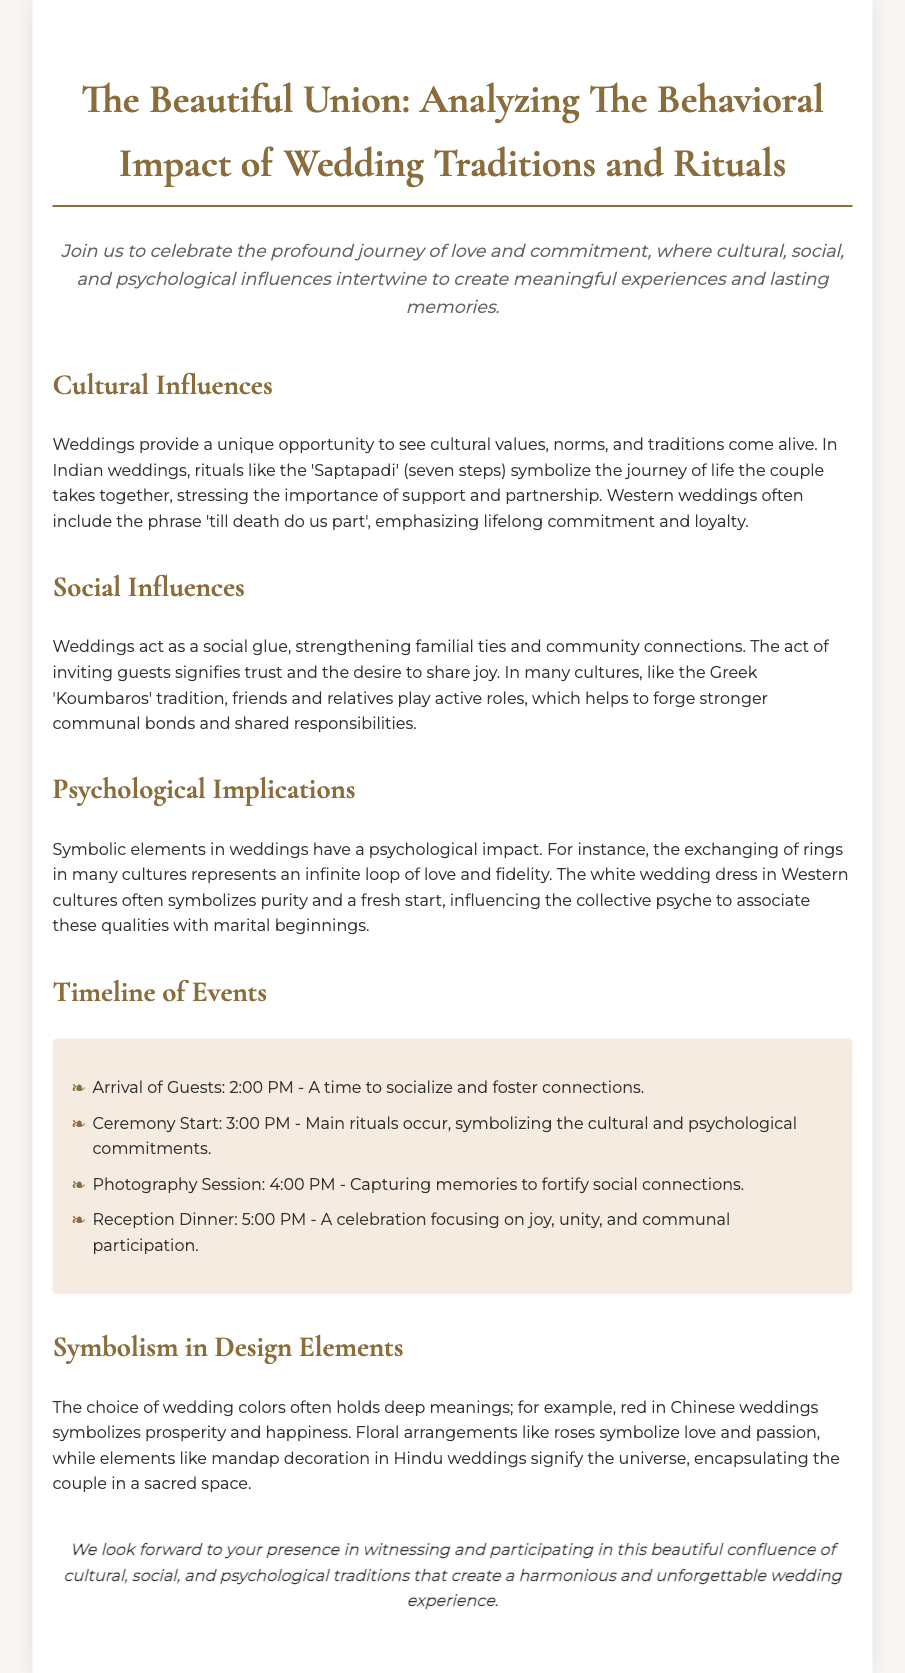What are the main cultural influences discussed? The cultural influences include rituals like 'Saptapadi' in Indian weddings and the phrase 'till death do us part' in Western weddings, showcasing the values and commitments of each culture.
Answer: 'Saptapadi', 'till death do us part' What time does the ceremony start? The document explicitly states the ceremony begins at 3:00 PM, indicating a unique part of the wedding timeline.
Answer: 3:00 PM What do the red colors symbolize in Chinese weddings? The document specifies that red in Chinese weddings symbolizes prosperity and happiness, highlighting its significance in cultural wedding elements.
Answer: Prosperity and happiness What is the role of the 'Koumbaros' tradition? The 'Koumbaros' tradition involves friends and relatives playing active roles in Greek weddings, reinforcing social connections and shared responsibilities among the community.
Answer: Strengthening communal bonds What does the white wedding dress symbolize in Western cultures? The white wedding dress is said to symbolize purity and a fresh start, influencing societal perceptions of marriage.
Answer: Purity and a fresh start 